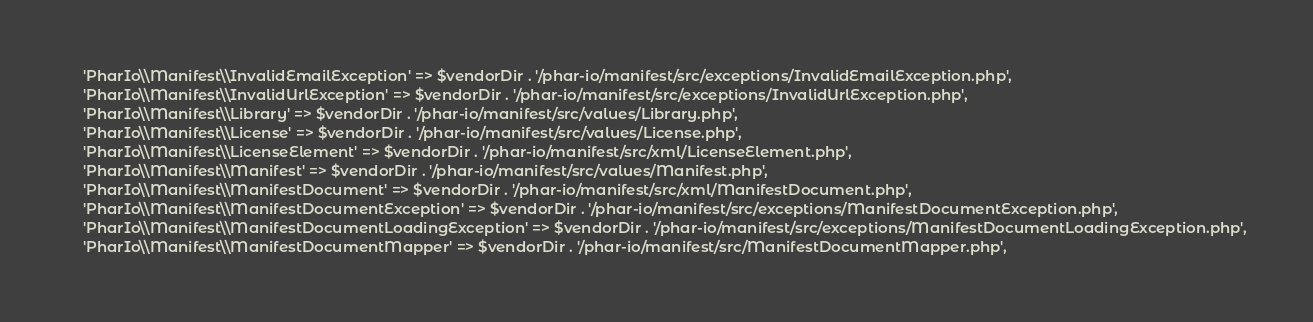<code> <loc_0><loc_0><loc_500><loc_500><_PHP_>    'PharIo\\Manifest\\InvalidEmailException' => $vendorDir . '/phar-io/manifest/src/exceptions/InvalidEmailException.php',
    'PharIo\\Manifest\\InvalidUrlException' => $vendorDir . '/phar-io/manifest/src/exceptions/InvalidUrlException.php',
    'PharIo\\Manifest\\Library' => $vendorDir . '/phar-io/manifest/src/values/Library.php',
    'PharIo\\Manifest\\License' => $vendorDir . '/phar-io/manifest/src/values/License.php',
    'PharIo\\Manifest\\LicenseElement' => $vendorDir . '/phar-io/manifest/src/xml/LicenseElement.php',
    'PharIo\\Manifest\\Manifest' => $vendorDir . '/phar-io/manifest/src/values/Manifest.php',
    'PharIo\\Manifest\\ManifestDocument' => $vendorDir . '/phar-io/manifest/src/xml/ManifestDocument.php',
    'PharIo\\Manifest\\ManifestDocumentException' => $vendorDir . '/phar-io/manifest/src/exceptions/ManifestDocumentException.php',
    'PharIo\\Manifest\\ManifestDocumentLoadingException' => $vendorDir . '/phar-io/manifest/src/exceptions/ManifestDocumentLoadingException.php',
    'PharIo\\Manifest\\ManifestDocumentMapper' => $vendorDir . '/phar-io/manifest/src/ManifestDocumentMapper.php',</code> 